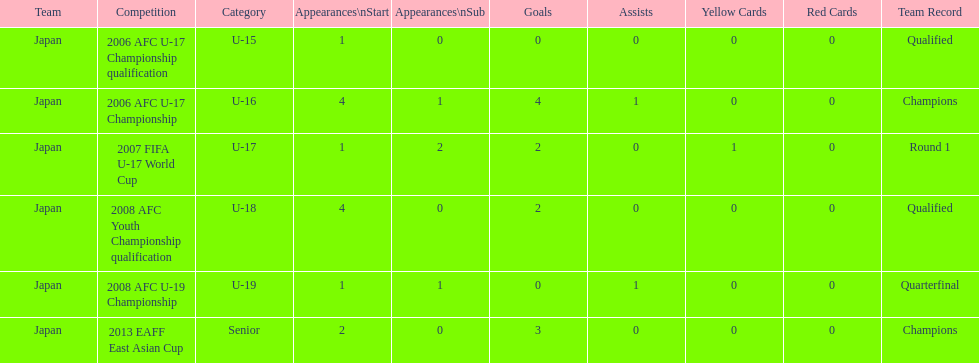What was yoichiro kakitani's first major competition? 2006 AFC U-17 Championship qualification. 